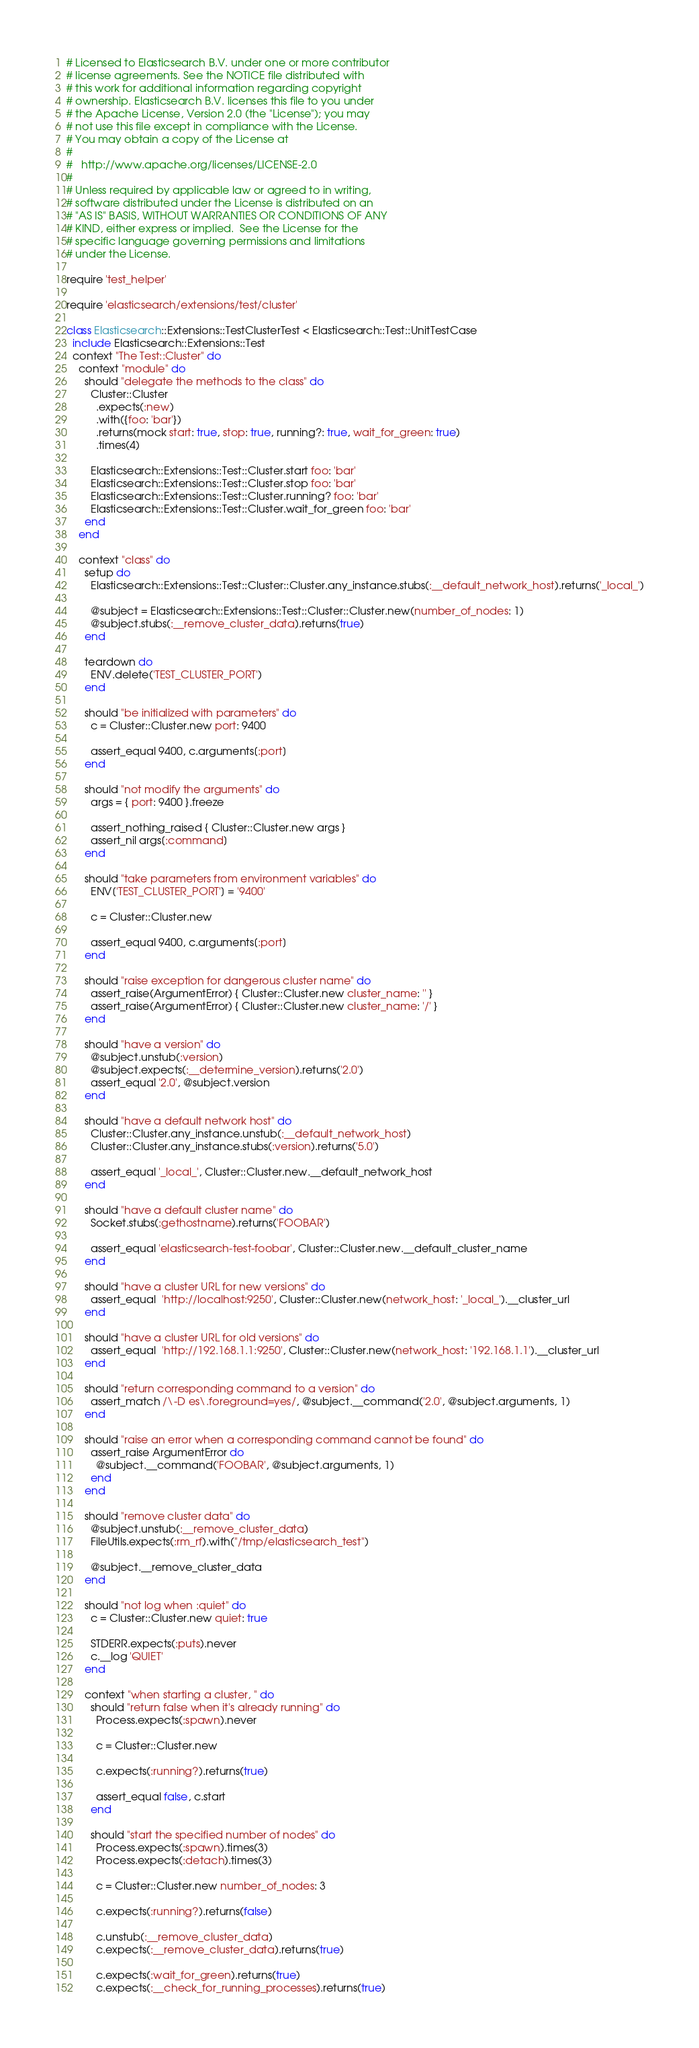Convert code to text. <code><loc_0><loc_0><loc_500><loc_500><_Ruby_># Licensed to Elasticsearch B.V. under one or more contributor
# license agreements. See the NOTICE file distributed with
# this work for additional information regarding copyright
# ownership. Elasticsearch B.V. licenses this file to you under
# the Apache License, Version 2.0 (the "License"); you may
# not use this file except in compliance with the License.
# You may obtain a copy of the License at
#
#	http://www.apache.org/licenses/LICENSE-2.0
#
# Unless required by applicable law or agreed to in writing,
# software distributed under the License is distributed on an
# "AS IS" BASIS, WITHOUT WARRANTIES OR CONDITIONS OF ANY
# KIND, either express or implied.  See the License for the
# specific language governing permissions and limitations
# under the License.

require 'test_helper'

require 'elasticsearch/extensions/test/cluster'

class Elasticsearch::Extensions::TestClusterTest < Elasticsearch::Test::UnitTestCase
  include Elasticsearch::Extensions::Test
  context "The Test::Cluster" do
    context "module" do
      should "delegate the methods to the class" do
        Cluster::Cluster
          .expects(:new)
          .with({foo: 'bar'})
          .returns(mock start: true, stop: true, running?: true, wait_for_green: true)
          .times(4)

        Elasticsearch::Extensions::Test::Cluster.start foo: 'bar'
        Elasticsearch::Extensions::Test::Cluster.stop foo: 'bar'
        Elasticsearch::Extensions::Test::Cluster.running? foo: 'bar'
        Elasticsearch::Extensions::Test::Cluster.wait_for_green foo: 'bar'
      end
    end

    context "class" do
      setup do
        Elasticsearch::Extensions::Test::Cluster::Cluster.any_instance.stubs(:__default_network_host).returns('_local_')

        @subject = Elasticsearch::Extensions::Test::Cluster::Cluster.new(number_of_nodes: 1)
        @subject.stubs(:__remove_cluster_data).returns(true)
      end

      teardown do
        ENV.delete('TEST_CLUSTER_PORT')
      end

      should "be initialized with parameters" do
        c = Cluster::Cluster.new port: 9400

        assert_equal 9400, c.arguments[:port]
      end

      should "not modify the arguments" do
        args = { port: 9400 }.freeze

        assert_nothing_raised { Cluster::Cluster.new args }
        assert_nil args[:command]
      end

      should "take parameters from environment variables" do
        ENV['TEST_CLUSTER_PORT'] = '9400'

        c = Cluster::Cluster.new

        assert_equal 9400, c.arguments[:port]
      end

      should "raise exception for dangerous cluster name" do
        assert_raise(ArgumentError) { Cluster::Cluster.new cluster_name: '' }
        assert_raise(ArgumentError) { Cluster::Cluster.new cluster_name: '/' }
      end

      should "have a version" do
        @subject.unstub(:version)
        @subject.expects(:__determine_version).returns('2.0')
        assert_equal '2.0', @subject.version
      end

      should "have a default network host" do
        Cluster::Cluster.any_instance.unstub(:__default_network_host)
        Cluster::Cluster.any_instance.stubs(:version).returns('5.0')

        assert_equal '_local_', Cluster::Cluster.new.__default_network_host
      end

      should "have a default cluster name" do
        Socket.stubs(:gethostname).returns('FOOBAR')

        assert_equal 'elasticsearch-test-foobar', Cluster::Cluster.new.__default_cluster_name
      end

      should "have a cluster URL for new versions" do
        assert_equal  'http://localhost:9250', Cluster::Cluster.new(network_host: '_local_').__cluster_url
      end

      should "have a cluster URL for old versions" do
        assert_equal  'http://192.168.1.1:9250', Cluster::Cluster.new(network_host: '192.168.1.1').__cluster_url
      end

      should "return corresponding command to a version" do
        assert_match /\-D es\.foreground=yes/, @subject.__command('2.0', @subject.arguments, 1)
      end

      should "raise an error when a corresponding command cannot be found" do
        assert_raise ArgumentError do
          @subject.__command('FOOBAR', @subject.arguments, 1)
        end
      end

      should "remove cluster data" do
        @subject.unstub(:__remove_cluster_data)
        FileUtils.expects(:rm_rf).with("/tmp/elasticsearch_test")

        @subject.__remove_cluster_data
      end

      should "not log when :quiet" do
        c = Cluster::Cluster.new quiet: true

        STDERR.expects(:puts).never
        c.__log 'QUIET'
      end

      context "when starting a cluster, " do
        should "return false when it's already running" do
          Process.expects(:spawn).never

          c = Cluster::Cluster.new

          c.expects(:running?).returns(true)

          assert_equal false, c.start
        end

        should "start the specified number of nodes" do
          Process.expects(:spawn).times(3)
          Process.expects(:detach).times(3)

          c = Cluster::Cluster.new number_of_nodes: 3

          c.expects(:running?).returns(false)

          c.unstub(:__remove_cluster_data)
          c.expects(:__remove_cluster_data).returns(true)

          c.expects(:wait_for_green).returns(true)
          c.expects(:__check_for_running_processes).returns(true)</code> 